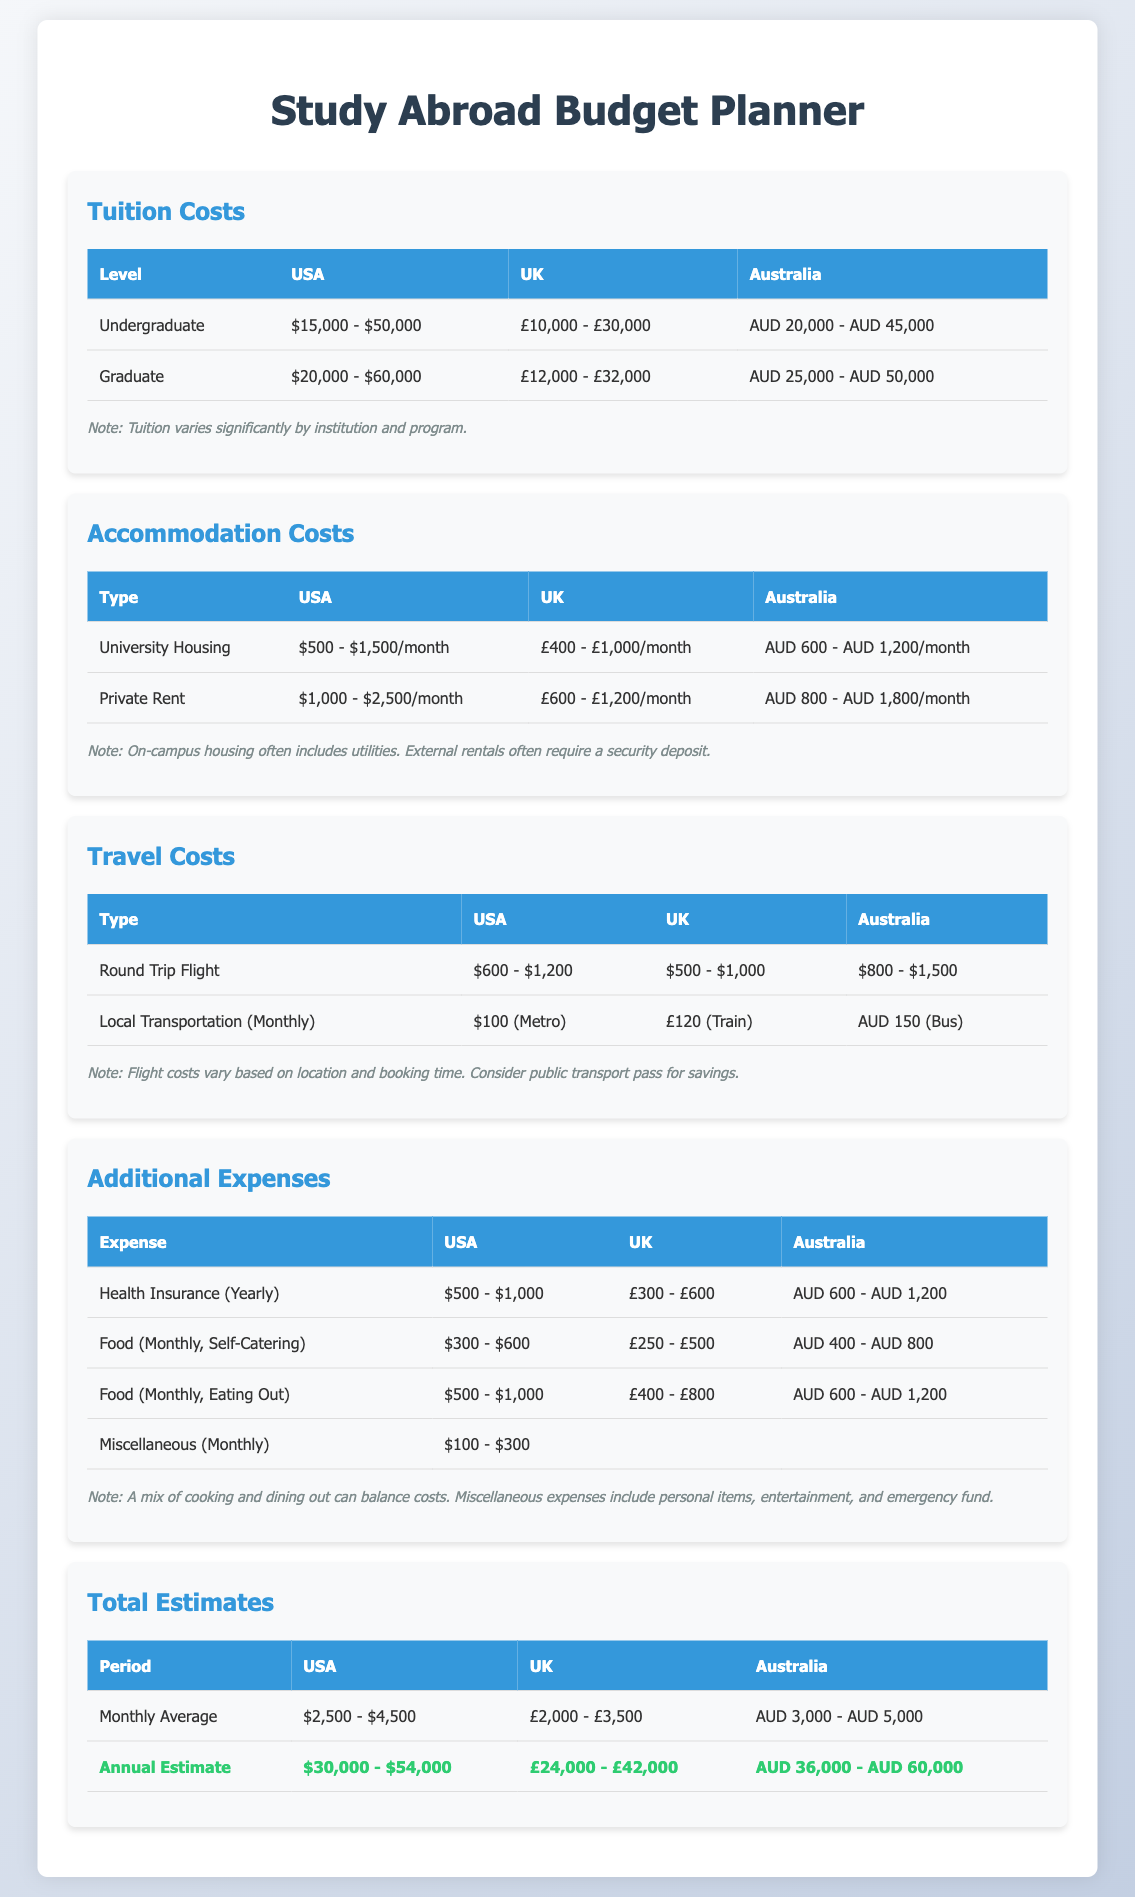What is the tuition cost range for undergraduate studies in the USA? The range for undergraduate tuition costs in the USA is $15,000 - $50,000.
Answer: $15,000 - $50,000 What is the monthly average estimate for studying in the UK? The monthly average estimate for studying in the UK is £2,000 - £3,500.
Answer: £2,000 - £3,500 What are the accommodation costs for private rent in Australia? The costs for private rent in Australia range from AUD 800 - AUD 1,800 per month.
Answer: AUD 800 - AUD 1,800 What is the cost of health insurance yearly in the USA? The yearly cost of health insurance in the USA is $500 - $1,000.
Answer: $500 - $1,000 What is the total annual estimate for studying in Australia? The total annual estimate for studying in Australia is AUD 36,000 - AUD 60,000.
Answer: AUD 36,000 - AUD 60,000 Which type of accommodation includes utilities in the USA? University housing often includes utilities.
Answer: University housing What is the cost for a round trip flight to the UK? The cost for a round trip flight to the UK ranges from $500 - $1,000.
Answer: $500 - $1,000 What miscellaneous expense is included in the additional costs table? Miscellaneous expenses include personal items, entertainment, and emergency fund.
Answer: Personal items, entertainment, and emergency fund What is the range for local transportation costs in Australia? The range for local transportation costs in Australia is AUD 150 (Bus) monthly.
Answer: AUD 150 (Bus) 